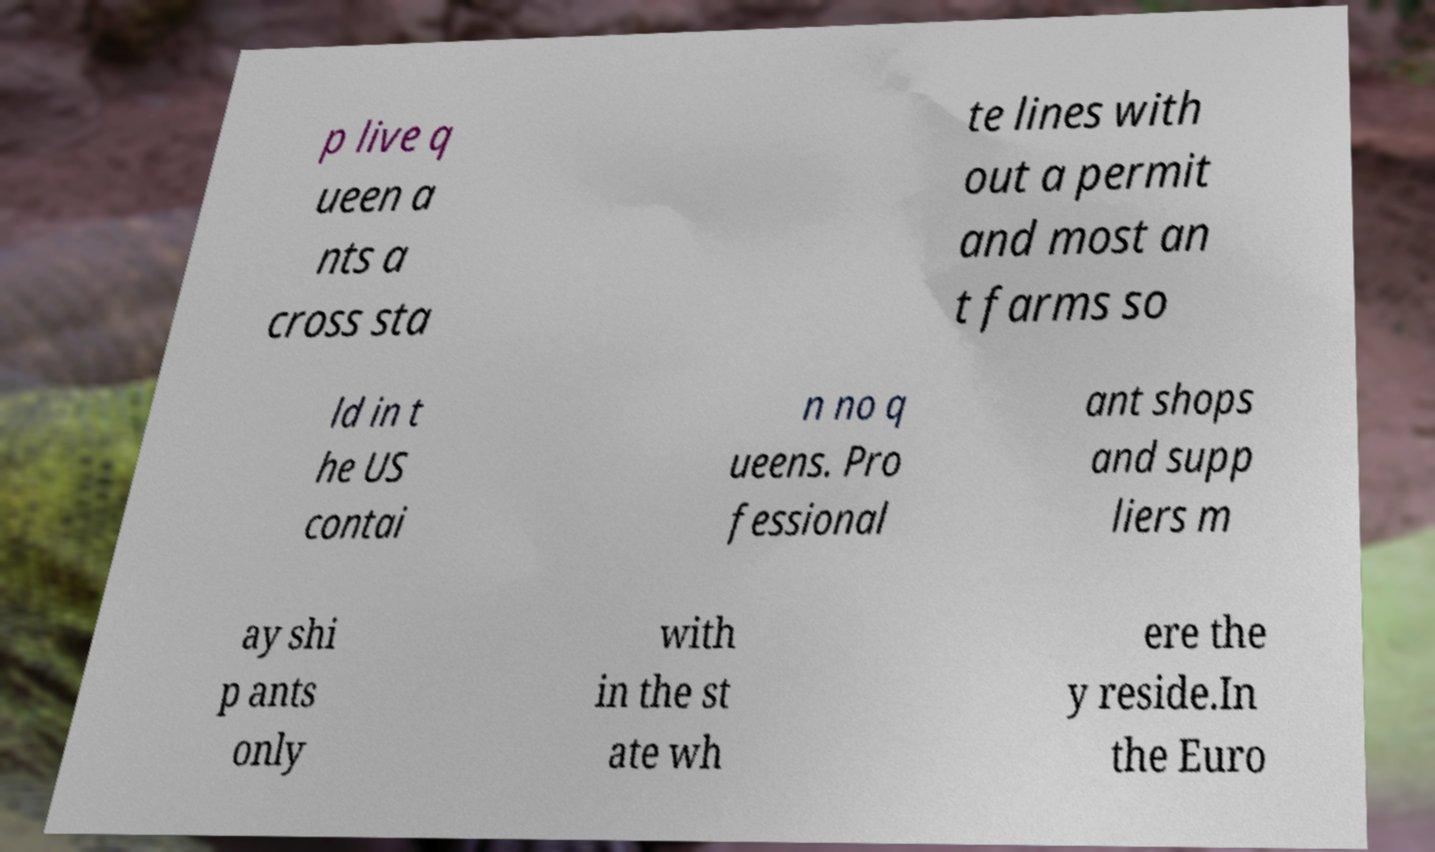I need the written content from this picture converted into text. Can you do that? p live q ueen a nts a cross sta te lines with out a permit and most an t farms so ld in t he US contai n no q ueens. Pro fessional ant shops and supp liers m ay shi p ants only with in the st ate wh ere the y reside.In the Euro 